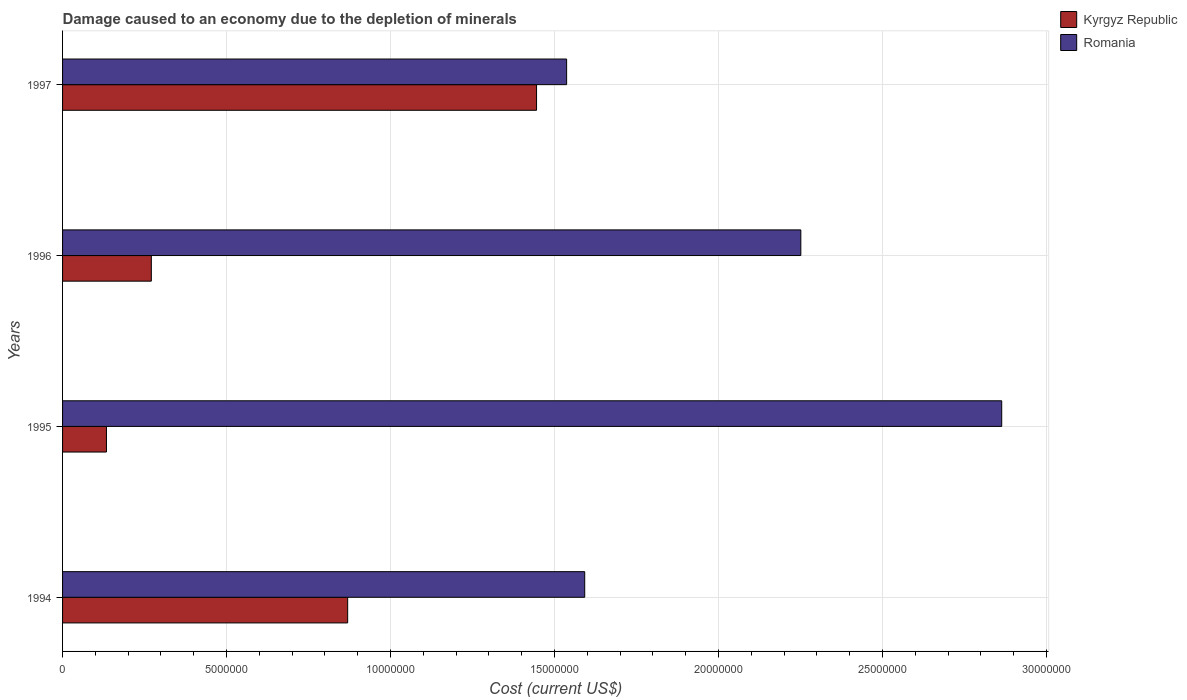How many different coloured bars are there?
Your response must be concise. 2. How many groups of bars are there?
Give a very brief answer. 4. Are the number of bars per tick equal to the number of legend labels?
Provide a succinct answer. Yes. How many bars are there on the 1st tick from the bottom?
Your answer should be very brief. 2. What is the label of the 2nd group of bars from the top?
Provide a short and direct response. 1996. What is the cost of damage caused due to the depletion of minerals in Kyrgyz Republic in 1996?
Your response must be concise. 2.71e+06. Across all years, what is the maximum cost of damage caused due to the depletion of minerals in Romania?
Your answer should be very brief. 2.86e+07. Across all years, what is the minimum cost of damage caused due to the depletion of minerals in Romania?
Make the answer very short. 1.54e+07. In which year was the cost of damage caused due to the depletion of minerals in Romania maximum?
Provide a short and direct response. 1995. What is the total cost of damage caused due to the depletion of minerals in Romania in the graph?
Ensure brevity in your answer.  8.24e+07. What is the difference between the cost of damage caused due to the depletion of minerals in Kyrgyz Republic in 1994 and that in 1997?
Offer a terse response. -5.76e+06. What is the difference between the cost of damage caused due to the depletion of minerals in Romania in 1994 and the cost of damage caused due to the depletion of minerals in Kyrgyz Republic in 1996?
Your answer should be compact. 1.32e+07. What is the average cost of damage caused due to the depletion of minerals in Romania per year?
Keep it short and to the point. 2.06e+07. In the year 1997, what is the difference between the cost of damage caused due to the depletion of minerals in Romania and cost of damage caused due to the depletion of minerals in Kyrgyz Republic?
Make the answer very short. 9.17e+05. What is the ratio of the cost of damage caused due to the depletion of minerals in Kyrgyz Republic in 1995 to that in 1997?
Ensure brevity in your answer.  0.09. Is the cost of damage caused due to the depletion of minerals in Romania in 1994 less than that in 1997?
Provide a succinct answer. No. Is the difference between the cost of damage caused due to the depletion of minerals in Romania in 1994 and 1995 greater than the difference between the cost of damage caused due to the depletion of minerals in Kyrgyz Republic in 1994 and 1995?
Offer a very short reply. No. What is the difference between the highest and the second highest cost of damage caused due to the depletion of minerals in Kyrgyz Republic?
Keep it short and to the point. 5.76e+06. What is the difference between the highest and the lowest cost of damage caused due to the depletion of minerals in Romania?
Provide a short and direct response. 1.33e+07. In how many years, is the cost of damage caused due to the depletion of minerals in Romania greater than the average cost of damage caused due to the depletion of minerals in Romania taken over all years?
Your answer should be very brief. 2. What does the 1st bar from the top in 1997 represents?
Give a very brief answer. Romania. What does the 1st bar from the bottom in 1995 represents?
Make the answer very short. Kyrgyz Republic. How many years are there in the graph?
Offer a very short reply. 4. What is the difference between two consecutive major ticks on the X-axis?
Offer a very short reply. 5.00e+06. What is the title of the graph?
Provide a succinct answer. Damage caused to an economy due to the depletion of minerals. Does "Samoa" appear as one of the legend labels in the graph?
Provide a short and direct response. No. What is the label or title of the X-axis?
Provide a short and direct response. Cost (current US$). What is the Cost (current US$) of Kyrgyz Republic in 1994?
Your answer should be compact. 8.69e+06. What is the Cost (current US$) in Romania in 1994?
Your answer should be very brief. 1.59e+07. What is the Cost (current US$) of Kyrgyz Republic in 1995?
Keep it short and to the point. 1.34e+06. What is the Cost (current US$) of Romania in 1995?
Your answer should be very brief. 2.86e+07. What is the Cost (current US$) of Kyrgyz Republic in 1996?
Offer a terse response. 2.71e+06. What is the Cost (current US$) of Romania in 1996?
Make the answer very short. 2.25e+07. What is the Cost (current US$) in Kyrgyz Republic in 1997?
Keep it short and to the point. 1.45e+07. What is the Cost (current US$) of Romania in 1997?
Your answer should be compact. 1.54e+07. Across all years, what is the maximum Cost (current US$) of Kyrgyz Republic?
Give a very brief answer. 1.45e+07. Across all years, what is the maximum Cost (current US$) in Romania?
Keep it short and to the point. 2.86e+07. Across all years, what is the minimum Cost (current US$) of Kyrgyz Republic?
Your answer should be very brief. 1.34e+06. Across all years, what is the minimum Cost (current US$) of Romania?
Offer a terse response. 1.54e+07. What is the total Cost (current US$) in Kyrgyz Republic in the graph?
Make the answer very short. 2.72e+07. What is the total Cost (current US$) in Romania in the graph?
Give a very brief answer. 8.24e+07. What is the difference between the Cost (current US$) in Kyrgyz Republic in 1994 and that in 1995?
Your response must be concise. 7.35e+06. What is the difference between the Cost (current US$) in Romania in 1994 and that in 1995?
Provide a succinct answer. -1.27e+07. What is the difference between the Cost (current US$) of Kyrgyz Republic in 1994 and that in 1996?
Ensure brevity in your answer.  5.99e+06. What is the difference between the Cost (current US$) in Romania in 1994 and that in 1996?
Offer a terse response. -6.59e+06. What is the difference between the Cost (current US$) in Kyrgyz Republic in 1994 and that in 1997?
Give a very brief answer. -5.76e+06. What is the difference between the Cost (current US$) of Romania in 1994 and that in 1997?
Make the answer very short. 5.52e+05. What is the difference between the Cost (current US$) in Kyrgyz Republic in 1995 and that in 1996?
Your answer should be compact. -1.37e+06. What is the difference between the Cost (current US$) of Romania in 1995 and that in 1996?
Provide a short and direct response. 6.12e+06. What is the difference between the Cost (current US$) of Kyrgyz Republic in 1995 and that in 1997?
Make the answer very short. -1.31e+07. What is the difference between the Cost (current US$) of Romania in 1995 and that in 1997?
Give a very brief answer. 1.33e+07. What is the difference between the Cost (current US$) in Kyrgyz Republic in 1996 and that in 1997?
Give a very brief answer. -1.17e+07. What is the difference between the Cost (current US$) of Romania in 1996 and that in 1997?
Your answer should be very brief. 7.14e+06. What is the difference between the Cost (current US$) of Kyrgyz Republic in 1994 and the Cost (current US$) of Romania in 1995?
Your response must be concise. -1.99e+07. What is the difference between the Cost (current US$) of Kyrgyz Republic in 1994 and the Cost (current US$) of Romania in 1996?
Make the answer very short. -1.38e+07. What is the difference between the Cost (current US$) in Kyrgyz Republic in 1994 and the Cost (current US$) in Romania in 1997?
Provide a succinct answer. -6.68e+06. What is the difference between the Cost (current US$) in Kyrgyz Republic in 1995 and the Cost (current US$) in Romania in 1996?
Keep it short and to the point. -2.12e+07. What is the difference between the Cost (current US$) in Kyrgyz Republic in 1995 and the Cost (current US$) in Romania in 1997?
Keep it short and to the point. -1.40e+07. What is the difference between the Cost (current US$) in Kyrgyz Republic in 1996 and the Cost (current US$) in Romania in 1997?
Your answer should be compact. -1.27e+07. What is the average Cost (current US$) in Kyrgyz Republic per year?
Provide a short and direct response. 6.80e+06. What is the average Cost (current US$) in Romania per year?
Offer a terse response. 2.06e+07. In the year 1994, what is the difference between the Cost (current US$) in Kyrgyz Republic and Cost (current US$) in Romania?
Give a very brief answer. -7.23e+06. In the year 1995, what is the difference between the Cost (current US$) of Kyrgyz Republic and Cost (current US$) of Romania?
Your response must be concise. -2.73e+07. In the year 1996, what is the difference between the Cost (current US$) in Kyrgyz Republic and Cost (current US$) in Romania?
Keep it short and to the point. -1.98e+07. In the year 1997, what is the difference between the Cost (current US$) in Kyrgyz Republic and Cost (current US$) in Romania?
Your answer should be compact. -9.17e+05. What is the ratio of the Cost (current US$) in Kyrgyz Republic in 1994 to that in 1995?
Your answer should be very brief. 6.49. What is the ratio of the Cost (current US$) in Romania in 1994 to that in 1995?
Ensure brevity in your answer.  0.56. What is the ratio of the Cost (current US$) in Kyrgyz Republic in 1994 to that in 1996?
Provide a succinct answer. 3.21. What is the ratio of the Cost (current US$) in Romania in 1994 to that in 1996?
Your answer should be compact. 0.71. What is the ratio of the Cost (current US$) of Kyrgyz Republic in 1994 to that in 1997?
Provide a short and direct response. 0.6. What is the ratio of the Cost (current US$) in Romania in 1994 to that in 1997?
Offer a terse response. 1.04. What is the ratio of the Cost (current US$) in Kyrgyz Republic in 1995 to that in 1996?
Ensure brevity in your answer.  0.49. What is the ratio of the Cost (current US$) in Romania in 1995 to that in 1996?
Provide a short and direct response. 1.27. What is the ratio of the Cost (current US$) of Kyrgyz Republic in 1995 to that in 1997?
Your answer should be compact. 0.09. What is the ratio of the Cost (current US$) of Romania in 1995 to that in 1997?
Provide a succinct answer. 1.86. What is the ratio of the Cost (current US$) in Kyrgyz Republic in 1996 to that in 1997?
Provide a succinct answer. 0.19. What is the ratio of the Cost (current US$) of Romania in 1996 to that in 1997?
Keep it short and to the point. 1.46. What is the difference between the highest and the second highest Cost (current US$) in Kyrgyz Republic?
Your answer should be compact. 5.76e+06. What is the difference between the highest and the second highest Cost (current US$) in Romania?
Provide a short and direct response. 6.12e+06. What is the difference between the highest and the lowest Cost (current US$) in Kyrgyz Republic?
Keep it short and to the point. 1.31e+07. What is the difference between the highest and the lowest Cost (current US$) of Romania?
Provide a succinct answer. 1.33e+07. 